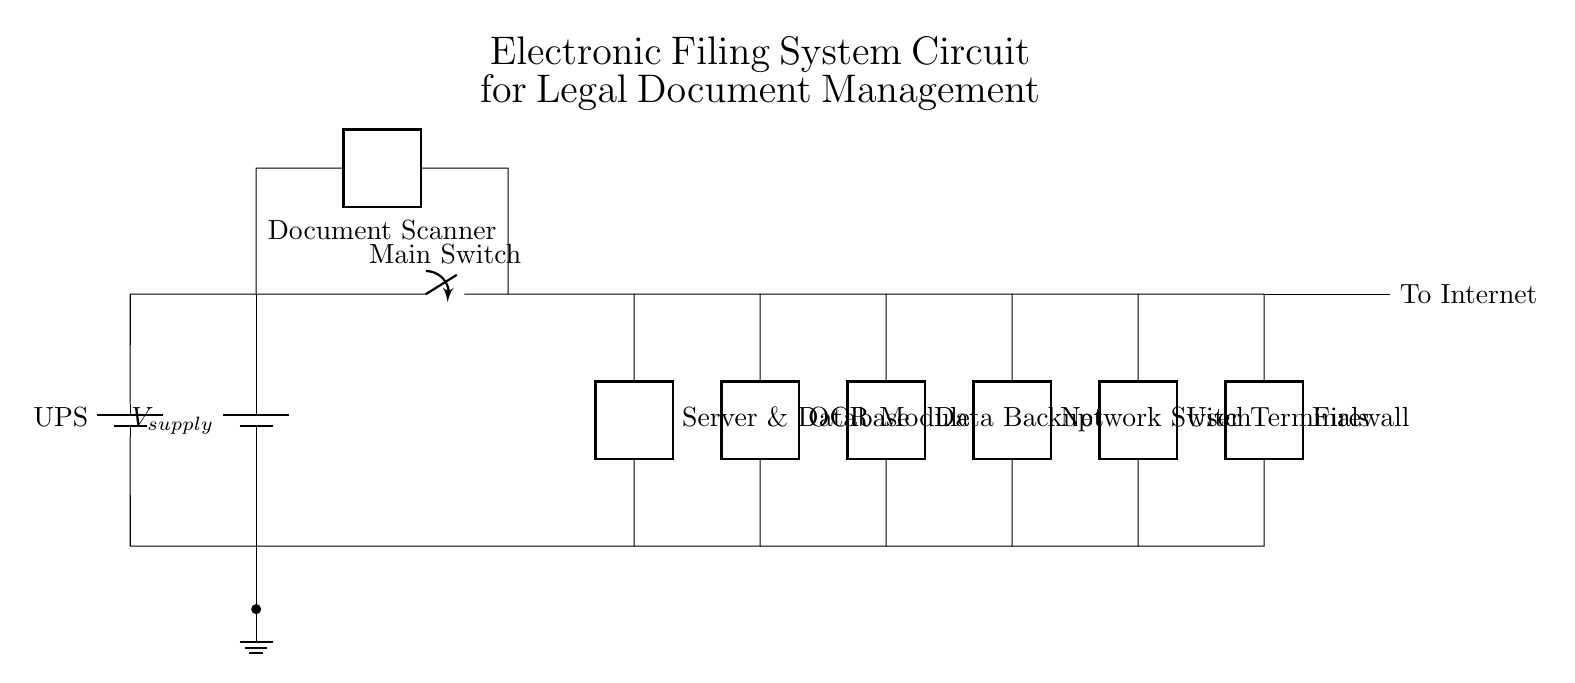What component is used for data backup? The circuit diagram indicates a component labeled "Data Backup" in the lower section, specifically connected to the OCR module and the network switch.
Answer: Data Backup What does the firewall protect? The firewall is connected after the user terminals and before the internet connection, indicating it is designed to protect the system from external threats from the internet.
Answer: Internet How many main components are there in the circuit? The circuit comprises a total of eight primary components: power supply, main switch, server and database, document scanner, OCR module, data backup system, network switch, and firewall.
Answer: Eight What is the role of the document scanner? The document scanner, identified in the upper section of the circuit, is responsible for capturing physical documents and converting them into digital format for further processing by the OCR module.
Answer: Capturing documents Explain the purpose of the UPS in this circuit. The Uninterruptible Power Supply (UPS) ensures that the circuit has a continuous power source even during outages, safeguarding critical components like the server and database, which are essential for legal document management.
Answer: Continuous power source What type of connection follows the network switch? The network switch is directly connected to the user terminals, facilitating communication and data transfer between the network and the end-users of the electronic filing system.
Answer: User terminals 